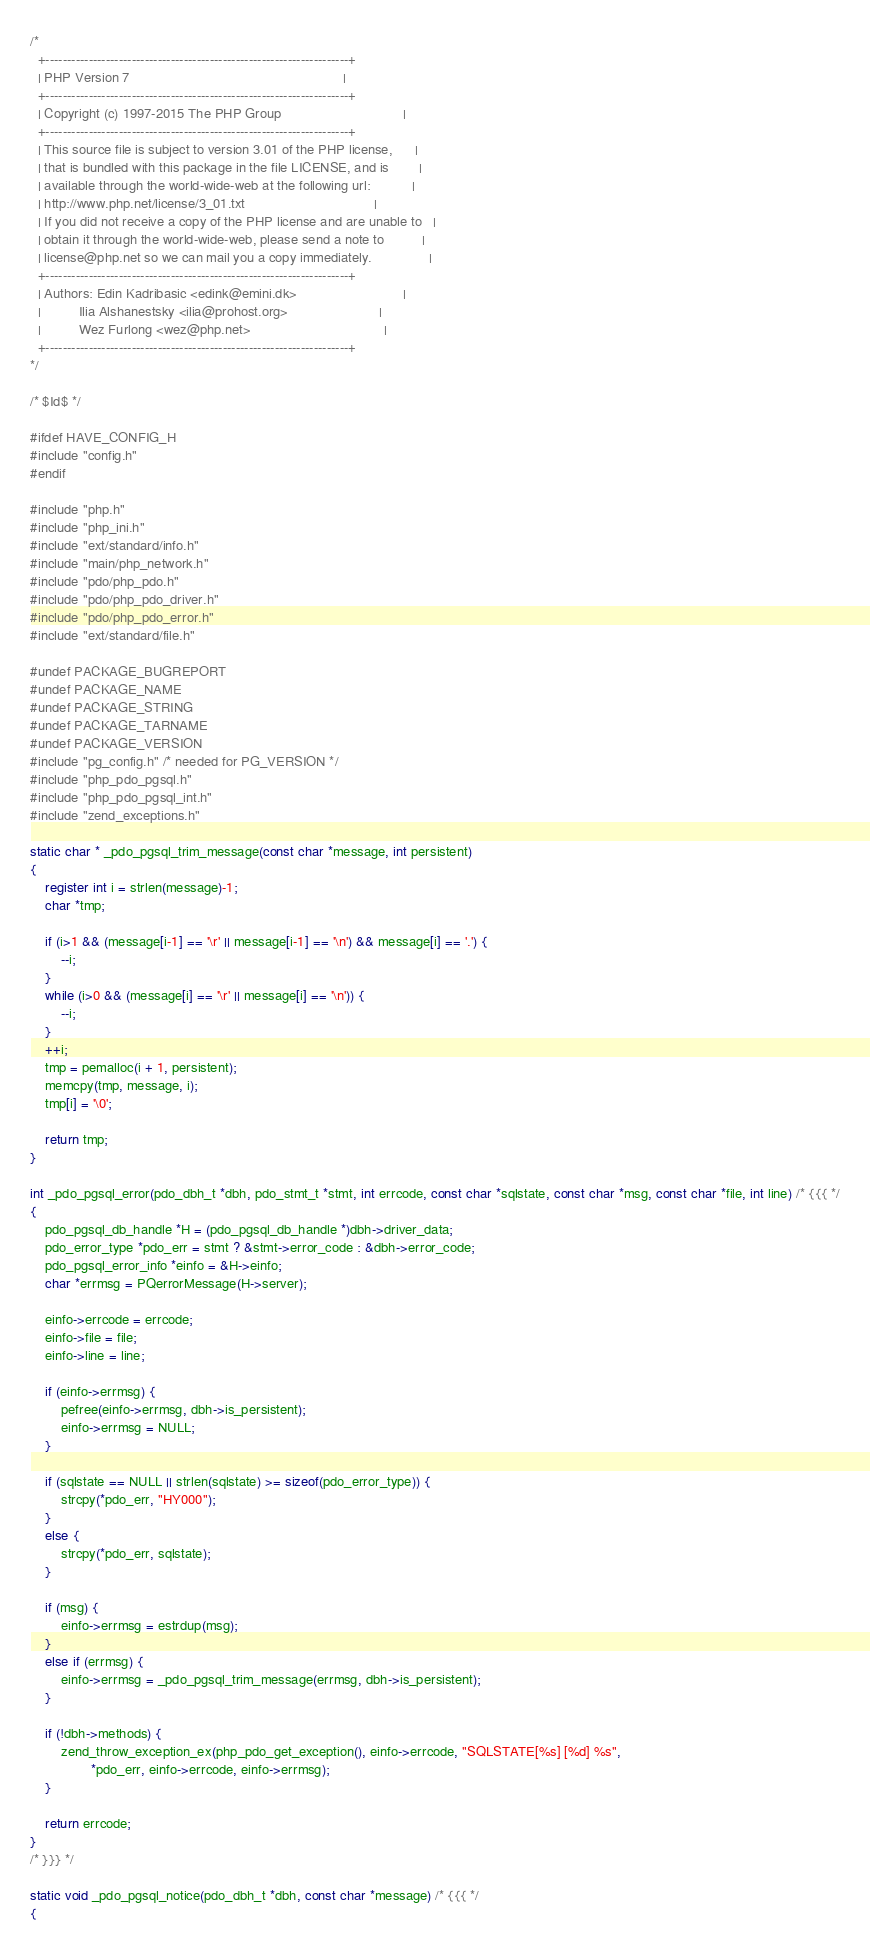Convert code to text. <code><loc_0><loc_0><loc_500><loc_500><_C_>/*
  +----------------------------------------------------------------------+
  | PHP Version 7                                                        |
  +----------------------------------------------------------------------+
  | Copyright (c) 1997-2015 The PHP Group                                |
  +----------------------------------------------------------------------+
  | This source file is subject to version 3.01 of the PHP license,      |
  | that is bundled with this package in the file LICENSE, and is        |
  | available through the world-wide-web at the following url:           |
  | http://www.php.net/license/3_01.txt                                  |
  | If you did not receive a copy of the PHP license and are unable to   |
  | obtain it through the world-wide-web, please send a note to          |
  | license@php.net so we can mail you a copy immediately.               |
  +----------------------------------------------------------------------+
  | Authors: Edin Kadribasic <edink@emini.dk>                            |
  |          Ilia Alshanestsky <ilia@prohost.org>                        |
  |          Wez Furlong <wez@php.net>                                   |
  +----------------------------------------------------------------------+
*/

/* $Id$ */

#ifdef HAVE_CONFIG_H
#include "config.h"
#endif

#include "php.h"
#include "php_ini.h"
#include "ext/standard/info.h"
#include "main/php_network.h"
#include "pdo/php_pdo.h"
#include "pdo/php_pdo_driver.h"
#include "pdo/php_pdo_error.h"
#include "ext/standard/file.h"

#undef PACKAGE_BUGREPORT
#undef PACKAGE_NAME
#undef PACKAGE_STRING
#undef PACKAGE_TARNAME
#undef PACKAGE_VERSION
#include "pg_config.h" /* needed for PG_VERSION */
#include "php_pdo_pgsql.h"
#include "php_pdo_pgsql_int.h"
#include "zend_exceptions.h"

static char * _pdo_pgsql_trim_message(const char *message, int persistent)
{
	register int i = strlen(message)-1;
	char *tmp;

	if (i>1 && (message[i-1] == '\r' || message[i-1] == '\n') && message[i] == '.') {
		--i;
	}
	while (i>0 && (message[i] == '\r' || message[i] == '\n')) {
		--i;
	}
	++i;
	tmp = pemalloc(i + 1, persistent);
	memcpy(tmp, message, i);
	tmp[i] = '\0';

	return tmp;
}

int _pdo_pgsql_error(pdo_dbh_t *dbh, pdo_stmt_t *stmt, int errcode, const char *sqlstate, const char *msg, const char *file, int line) /* {{{ */
{
	pdo_pgsql_db_handle *H = (pdo_pgsql_db_handle *)dbh->driver_data;
	pdo_error_type *pdo_err = stmt ? &stmt->error_code : &dbh->error_code;
	pdo_pgsql_error_info *einfo = &H->einfo;
	char *errmsg = PQerrorMessage(H->server);

	einfo->errcode = errcode;
	einfo->file = file;
	einfo->line = line;

	if (einfo->errmsg) {
		pefree(einfo->errmsg, dbh->is_persistent);
		einfo->errmsg = NULL;
	}

	if (sqlstate == NULL || strlen(sqlstate) >= sizeof(pdo_error_type)) {
		strcpy(*pdo_err, "HY000");
	}
	else {
		strcpy(*pdo_err, sqlstate);
	}

	if (msg) {
		einfo->errmsg = estrdup(msg);
	}
	else if (errmsg) {
		einfo->errmsg = _pdo_pgsql_trim_message(errmsg, dbh->is_persistent);
	}

	if (!dbh->methods) {
		zend_throw_exception_ex(php_pdo_get_exception(), einfo->errcode, "SQLSTATE[%s] [%d] %s",
				*pdo_err, einfo->errcode, einfo->errmsg);
	}

	return errcode;
}
/* }}} */

static void _pdo_pgsql_notice(pdo_dbh_t *dbh, const char *message) /* {{{ */
{</code> 